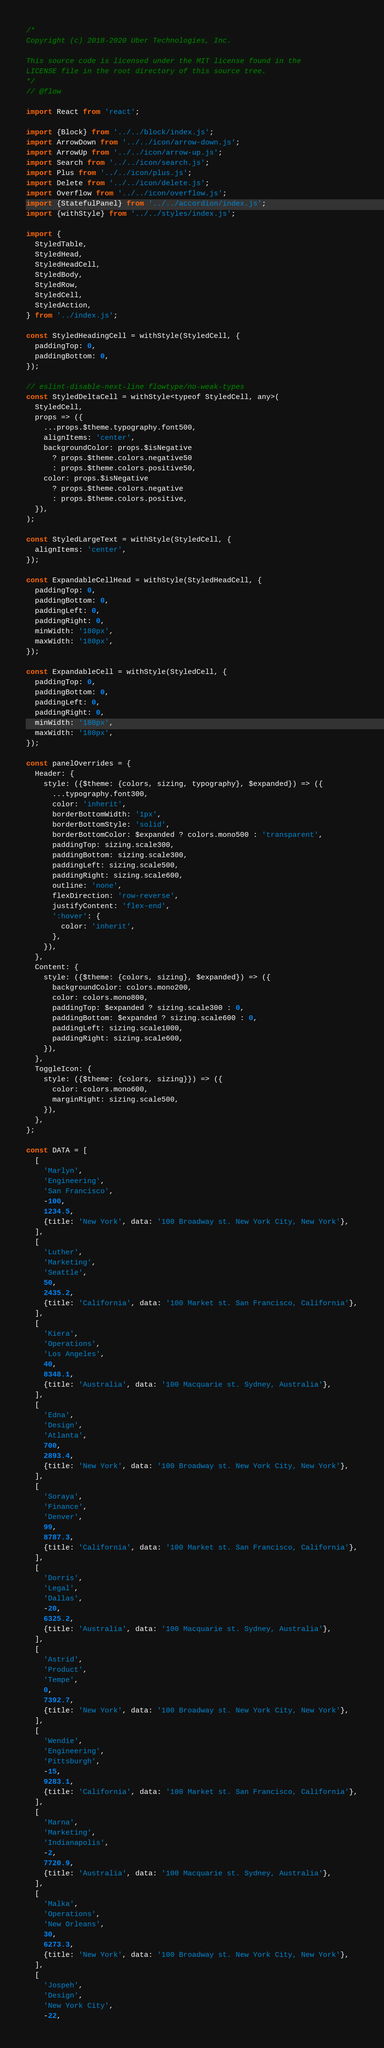Convert code to text. <code><loc_0><loc_0><loc_500><loc_500><_JavaScript_>/*
Copyright (c) 2018-2020 Uber Technologies, Inc.

This source code is licensed under the MIT license found in the
LICENSE file in the root directory of this source tree.
*/
// @flow

import React from 'react';

import {Block} from '../../block/index.js';
import ArrowDown from '../../icon/arrow-down.js';
import ArrowUp from '../../icon/arrow-up.js';
import Search from '../../icon/search.js';
import Plus from '../../icon/plus.js';
import Delete from '../../icon/delete.js';
import Overflow from '../../icon/overflow.js';
import {StatefulPanel} from '../../accordion/index.js';
import {withStyle} from '../../styles/index.js';

import {
  StyledTable,
  StyledHead,
  StyledHeadCell,
  StyledBody,
  StyledRow,
  StyledCell,
  StyledAction,
} from '../index.js';

const StyledHeadingCell = withStyle(StyledCell, {
  paddingTop: 0,
  paddingBottom: 0,
});

// eslint-disable-next-line flowtype/no-weak-types
const StyledDeltaCell = withStyle<typeof StyledCell, any>(
  StyledCell,
  props => ({
    ...props.$theme.typography.font500,
    alignItems: 'center',
    backgroundColor: props.$isNegative
      ? props.$theme.colors.negative50
      : props.$theme.colors.positive50,
    color: props.$isNegative
      ? props.$theme.colors.negative
      : props.$theme.colors.positive,
  }),
);

const StyledLargeText = withStyle(StyledCell, {
  alignItems: 'center',
});

const ExpandableCellHead = withStyle(StyledHeadCell, {
  paddingTop: 0,
  paddingBottom: 0,
  paddingLeft: 0,
  paddingRight: 0,
  minWidth: '180px',
  maxWidth: '180px',
});

const ExpandableCell = withStyle(StyledCell, {
  paddingTop: 0,
  paddingBottom: 0,
  paddingLeft: 0,
  paddingRight: 0,
  minWidth: '180px',
  maxWidth: '180px',
});

const panelOverrides = {
  Header: {
    style: ({$theme: {colors, sizing, typography}, $expanded}) => ({
      ...typography.font300,
      color: 'inherit',
      borderBottomWidth: '1px',
      borderBottomStyle: 'solid',
      borderBottomColor: $expanded ? colors.mono500 : 'transparent',
      paddingTop: sizing.scale300,
      paddingBottom: sizing.scale300,
      paddingLeft: sizing.scale500,
      paddingRight: sizing.scale600,
      outline: 'none',
      flexDirection: 'row-reverse',
      justifyContent: 'flex-end',
      ':hover': {
        color: 'inherit',
      },
    }),
  },
  Content: {
    style: ({$theme: {colors, sizing}, $expanded}) => ({
      backgroundColor: colors.mono200,
      color: colors.mono800,
      paddingTop: $expanded ? sizing.scale300 : 0,
      paddingBottom: $expanded ? sizing.scale600 : 0,
      paddingLeft: sizing.scale1000,
      paddingRight: sizing.scale600,
    }),
  },
  ToggleIcon: {
    style: ({$theme: {colors, sizing}}) => ({
      color: colors.mono600,
      marginRight: sizing.scale500,
    }),
  },
};

const DATA = [
  [
    'Marlyn',
    'Engineering',
    'San Francisco',
    -100,
    1234.5,
    {title: 'New York', data: '100 Broadway st. New York City, New York'},
  ],
  [
    'Luther',
    'Marketing',
    'Seattle',
    50,
    2435.2,
    {title: 'California', data: '100 Market st. San Francisco, California'},
  ],
  [
    'Kiera',
    'Operations',
    'Los Angeles',
    40,
    8348.1,
    {title: 'Australia', data: '100 Macquarie st. Sydney, Australia'},
  ],
  [
    'Edna',
    'Design',
    'Atlanta',
    700,
    2893.4,
    {title: 'New York', data: '100 Broadway st. New York City, New York'},
  ],
  [
    'Soraya',
    'Finance',
    'Denver',
    99,
    8787.3,
    {title: 'California', data: '100 Market st. San Francisco, California'},
  ],
  [
    'Dorris',
    'Legal',
    'Dallas',
    -20,
    6325.2,
    {title: 'Australia', data: '100 Macquarie st. Sydney, Australia'},
  ],
  [
    'Astrid',
    'Product',
    'Tempe',
    0,
    7392.7,
    {title: 'New York', data: '100 Broadway st. New York City, New York'},
  ],
  [
    'Wendie',
    'Engineering',
    'Pittsburgh',
    -15,
    9283.1,
    {title: 'California', data: '100 Market st. San Francisco, California'},
  ],
  [
    'Marna',
    'Marketing',
    'Indianapolis',
    -2,
    7720.9,
    {title: 'Australia', data: '100 Macquarie st. Sydney, Australia'},
  ],
  [
    'Malka',
    'Operations',
    'New Orleans',
    30,
    6273.3,
    {title: 'New York', data: '100 Broadway st. New York City, New York'},
  ],
  [
    'Jospeh',
    'Design',
    'New York City',
    -22,</code> 